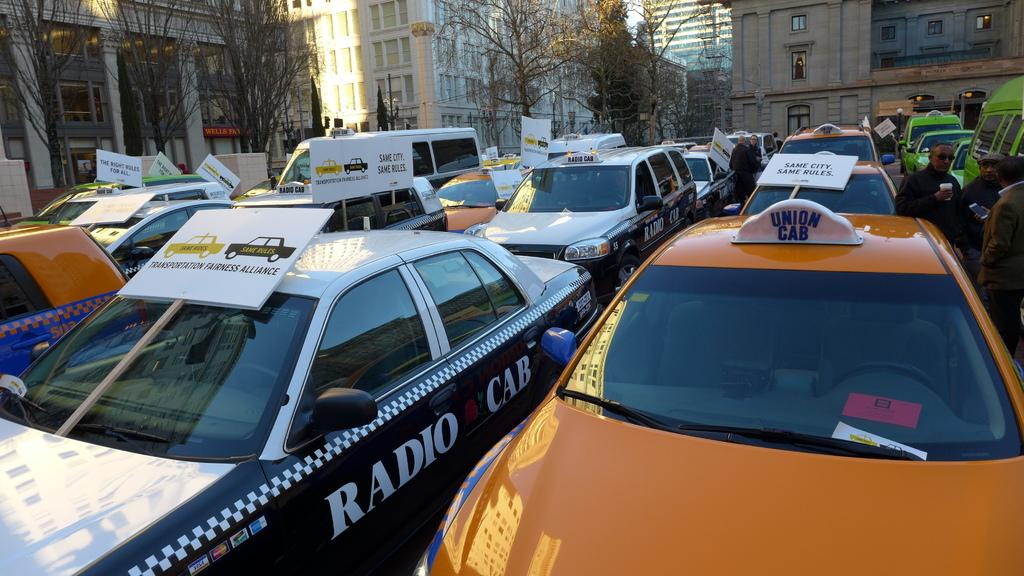<image>
Present a compact description of the photo's key features. A group of cabs lined up with signs citing fairness and rules 